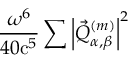Convert formula to latex. <formula><loc_0><loc_0><loc_500><loc_500>\frac { \omega ^ { 6 } } { 4 0 c ^ { 5 } } \sum \left | \vec { Q } _ { \alpha , \beta } ^ { ( m ) } \right | ^ { 2 }</formula> 